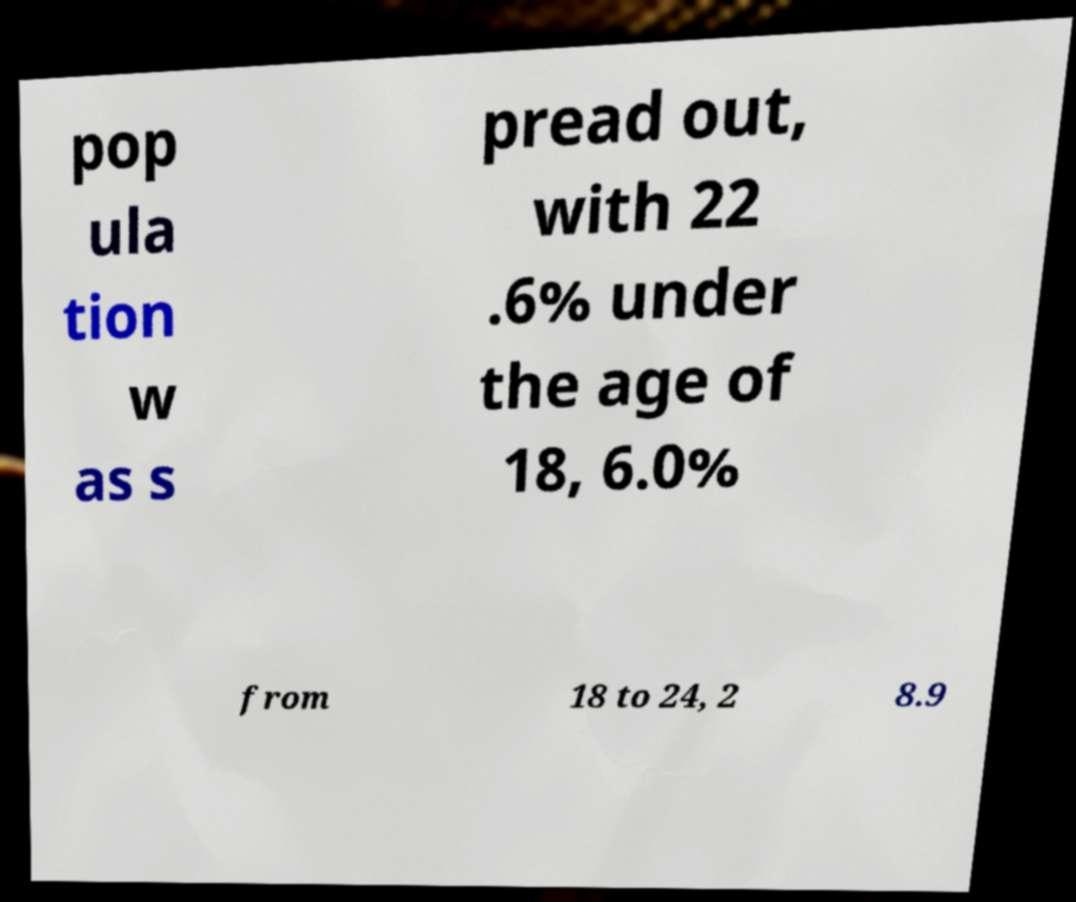Could you assist in decoding the text presented in this image and type it out clearly? pop ula tion w as s pread out, with 22 .6% under the age of 18, 6.0% from 18 to 24, 2 8.9 